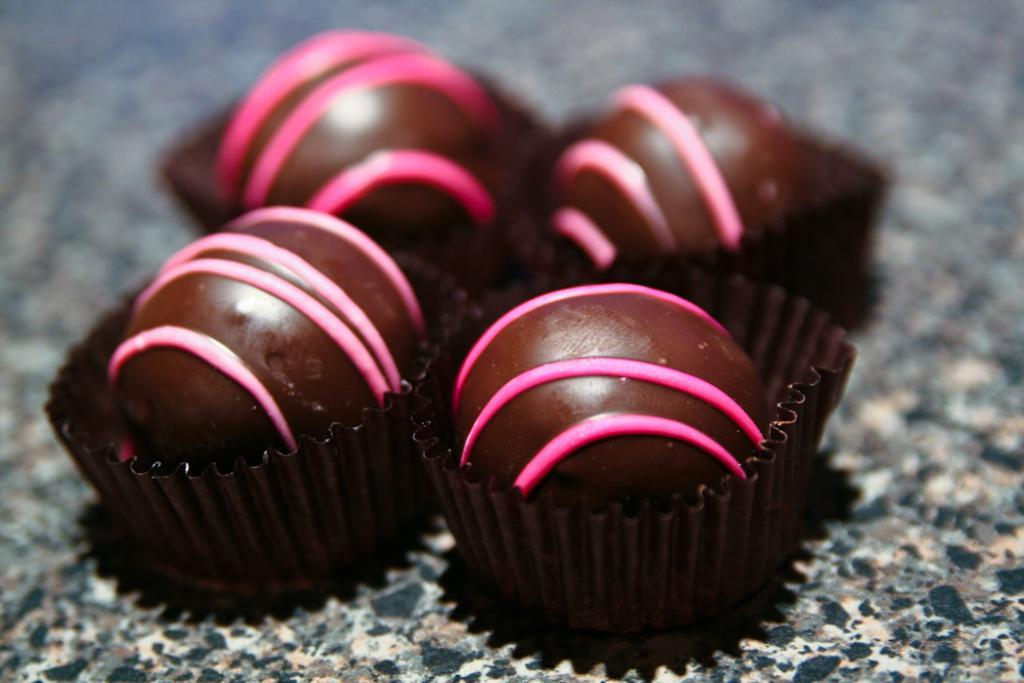What type of items can be seen in the image? The image contains food. What type of camp can be seen in the image? There is no camp present in the image; it contains food. How does the food contribute to the health of the individuals in the image? The image does not provide any information about the health of the individuals or the nutritional value of the food. 